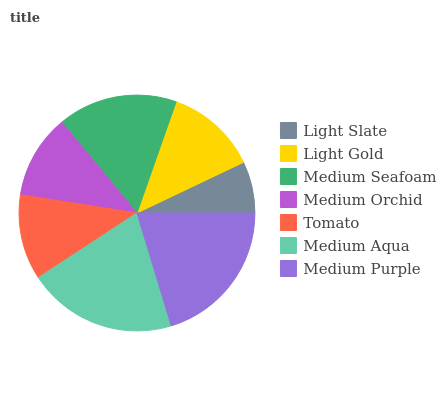Is Light Slate the minimum?
Answer yes or no. Yes. Is Medium Aqua the maximum?
Answer yes or no. Yes. Is Light Gold the minimum?
Answer yes or no. No. Is Light Gold the maximum?
Answer yes or no. No. Is Light Gold greater than Light Slate?
Answer yes or no. Yes. Is Light Slate less than Light Gold?
Answer yes or no. Yes. Is Light Slate greater than Light Gold?
Answer yes or no. No. Is Light Gold less than Light Slate?
Answer yes or no. No. Is Light Gold the high median?
Answer yes or no. Yes. Is Light Gold the low median?
Answer yes or no. Yes. Is Medium Purple the high median?
Answer yes or no. No. Is Medium Orchid the low median?
Answer yes or no. No. 